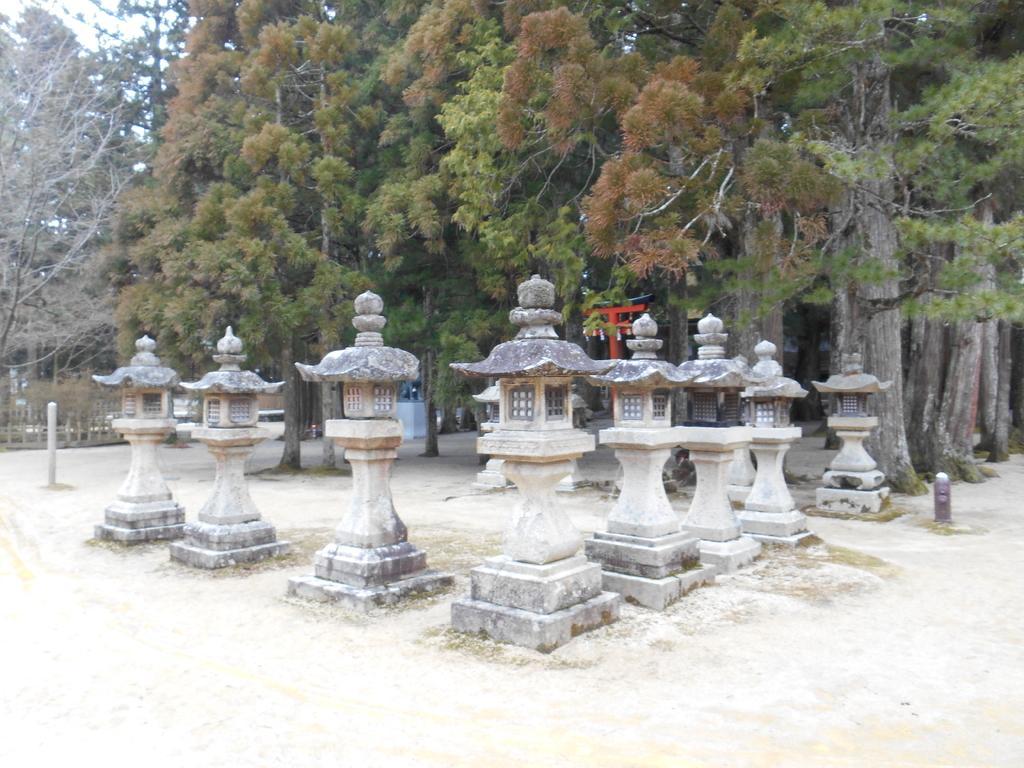Could you give a brief overview of what you see in this image? In this image I can see few pillars, trees in green color and the sky is in white color. 